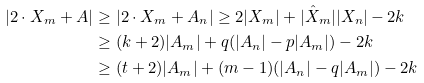<formula> <loc_0><loc_0><loc_500><loc_500>| 2 \cdot X _ { m } + A | & \geq | 2 \cdot X _ { m } + A _ { n } | \geq 2 | X _ { m } | + | \hat { X } _ { m } | | X _ { n } | - 2 k \\ & \geq ( k + 2 ) | A _ { m } | + q ( | A _ { n } | - p | A _ { m } | ) - 2 k \\ & \geq ( t + 2 ) | A _ { m } | + ( m - 1 ) ( | A _ { n } | - q | A _ { m } | ) - 2 k</formula> 